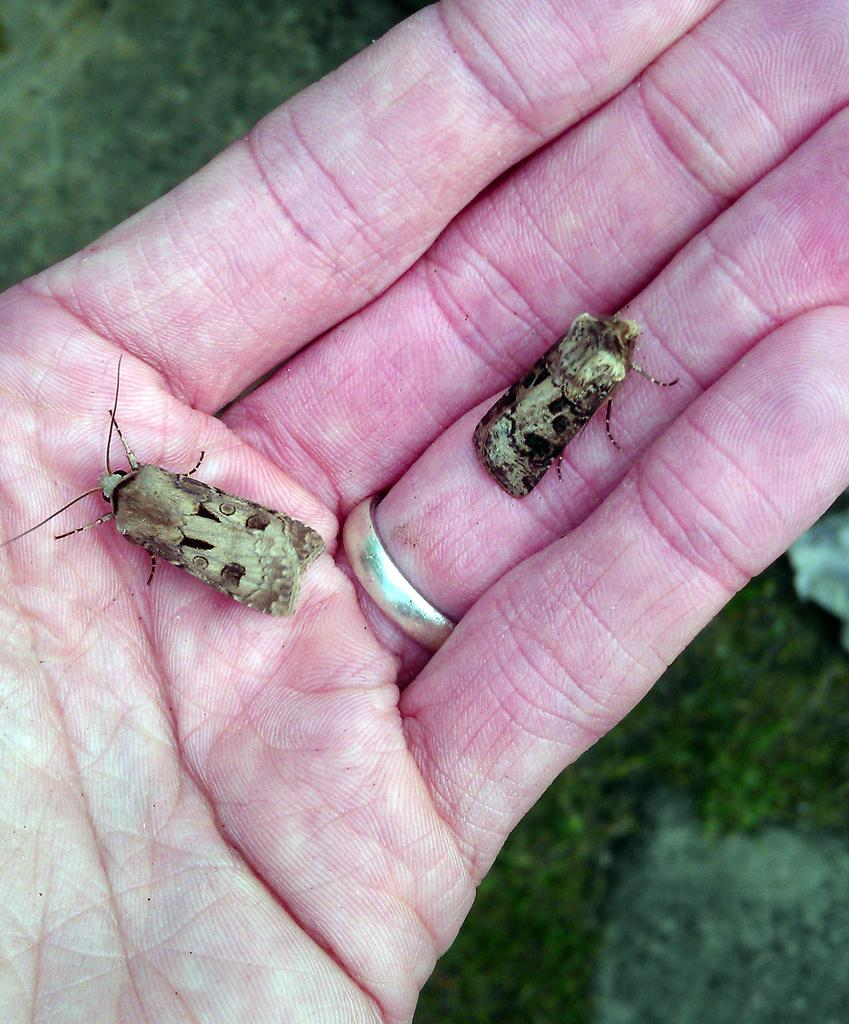What is happening in the image involving the hand? There are insects on a hand in the image. What can be seen in the background of the image? There are green leaves in the background of the image. What type of manager is overseeing the comfort of the insects in the image? There is no manager or reference to comfort in the image; it simply shows insects on a hand and green leaves in the background. 